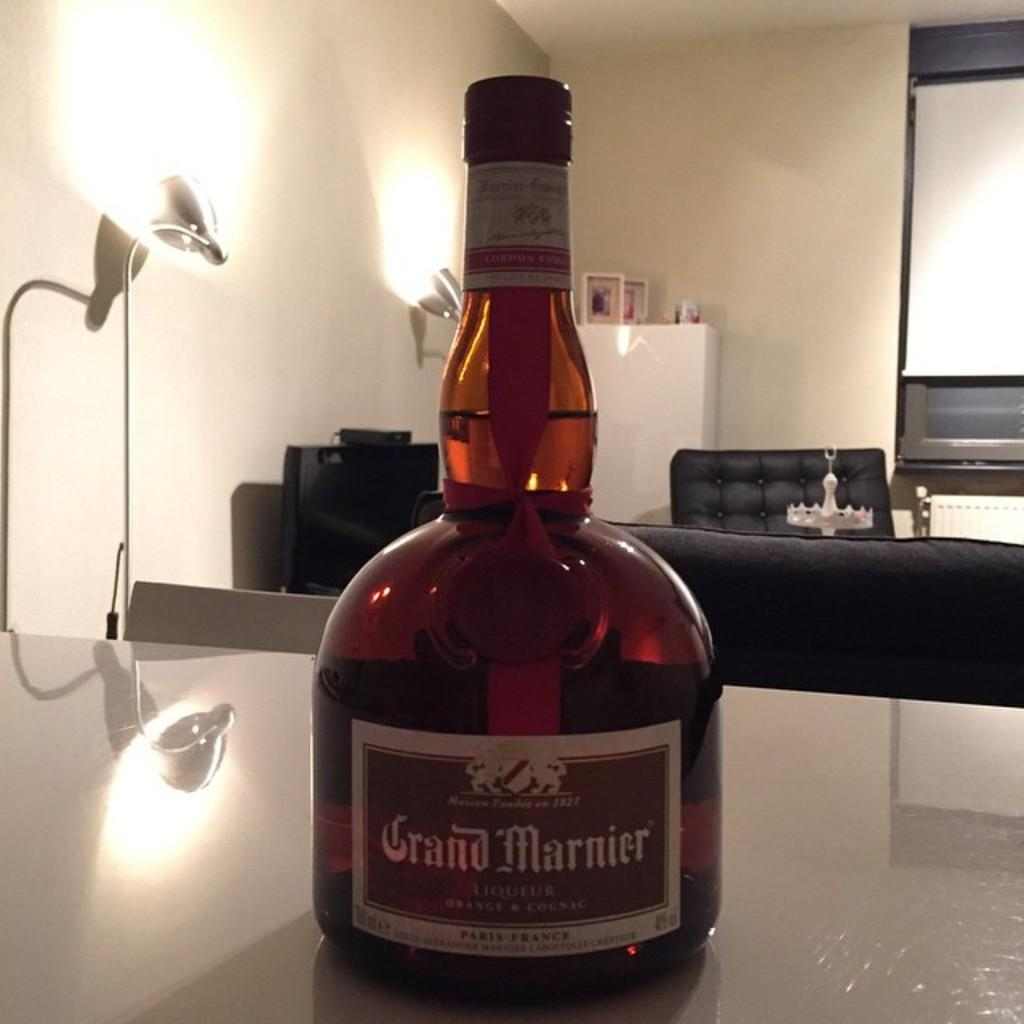<image>
Summarize the visual content of the image. Bottle of Grand Marnier liquor on a table 